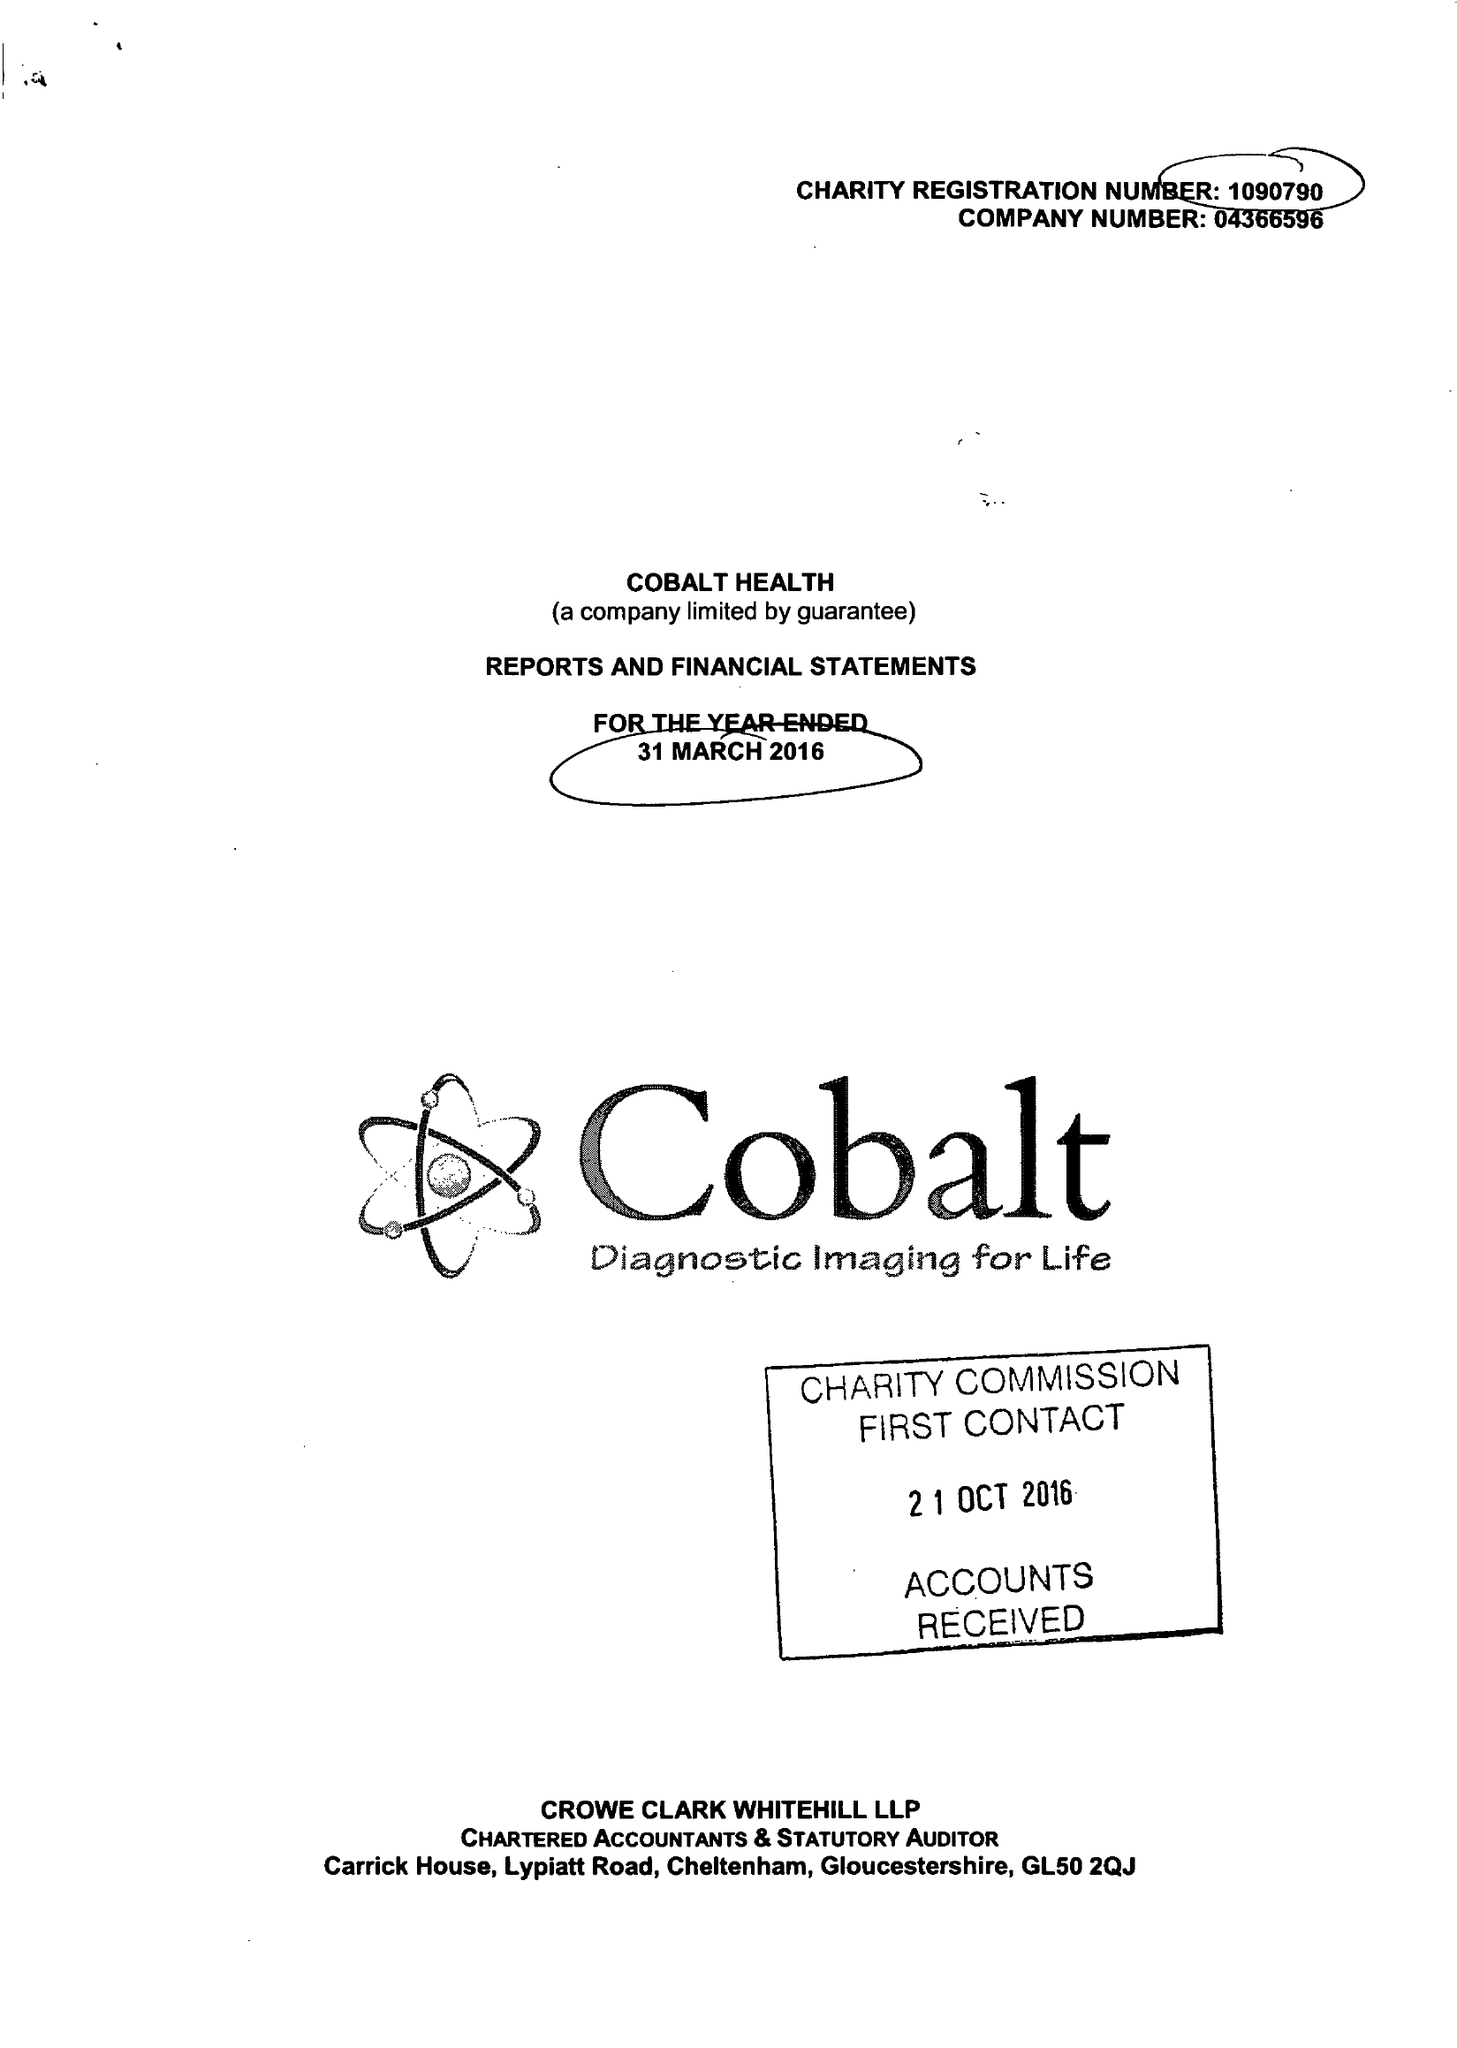What is the value for the address__post_town?
Answer the question using a single word or phrase. CHELTENHAM 